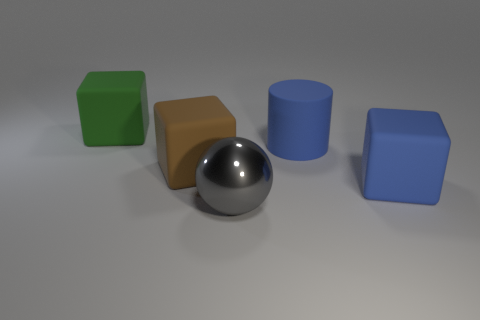Add 4 big blue blocks. How many objects exist? 9 Subtract all balls. How many objects are left? 4 Subtract 0 red cylinders. How many objects are left? 5 Subtract all tiny red metallic cubes. Subtract all large blue cylinders. How many objects are left? 4 Add 5 rubber objects. How many rubber objects are left? 9 Add 5 small blue matte spheres. How many small blue matte spheres exist? 5 